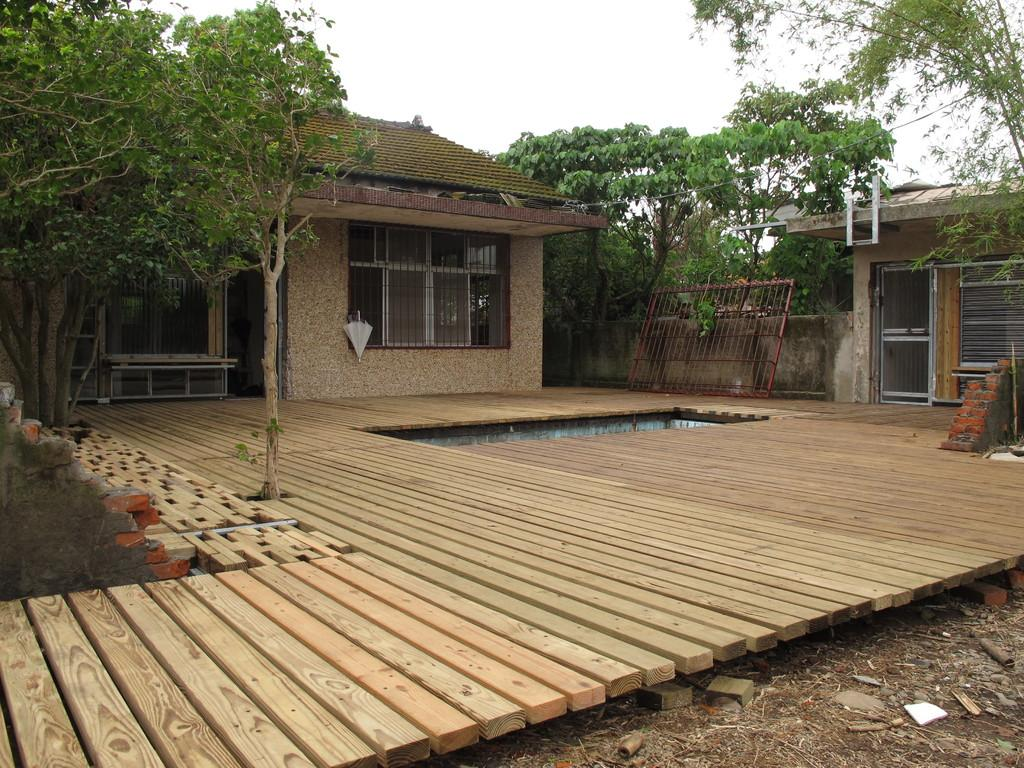What type of structures can be seen in the image? There are houses in the image. What is the wooden structure in the image used for? There is a wooden platform in the image, which could be used for various purposes such as a stage or a viewing platform. What type of vegetation is present in the image? There are trees in the image. What can be seen in the background of the image? The sky is visible in the background of the image. What is visible at the bottom of the image? The ground is visible in the image. What type of barriers are present in the image? There are walls in the image. What type of oil can be seen dripping from the trees in the image? There is no oil present in the image; it features houses, a wooden platform, trees, the sky, the ground, and walls. 